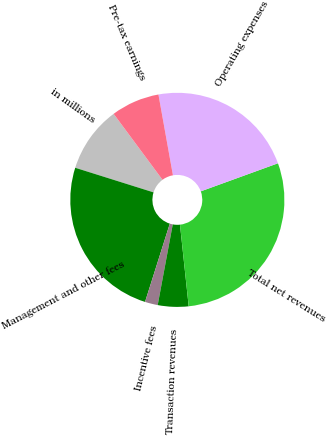Convert chart. <chart><loc_0><loc_0><loc_500><loc_500><pie_chart><fcel>in millions<fcel>Management and other fees<fcel>Incentive fees<fcel>Transaction revenues<fcel>Total net revenues<fcel>Operating expenses<fcel>Pre-tax earnings<nl><fcel>10.01%<fcel>24.97%<fcel>1.94%<fcel>4.63%<fcel>28.86%<fcel>22.28%<fcel>7.32%<nl></chart> 